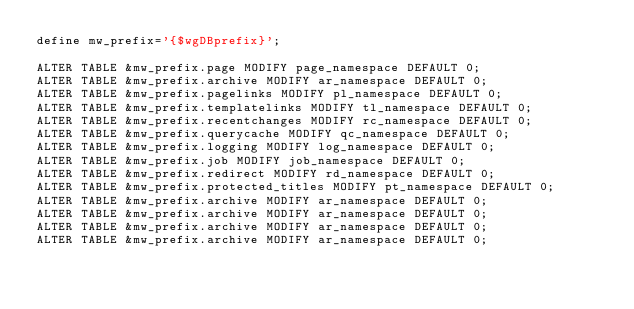<code> <loc_0><loc_0><loc_500><loc_500><_SQL_>define mw_prefix='{$wgDBprefix}';

ALTER TABLE &mw_prefix.page MODIFY page_namespace DEFAULT 0;
ALTER TABLE &mw_prefix.archive MODIFY ar_namespace DEFAULT 0;
ALTER TABLE &mw_prefix.pagelinks MODIFY pl_namespace DEFAULT 0;
ALTER TABLE &mw_prefix.templatelinks MODIFY tl_namespace DEFAULT 0;
ALTER TABLE &mw_prefix.recentchanges MODIFY rc_namespace DEFAULT 0;
ALTER TABLE &mw_prefix.querycache MODIFY qc_namespace DEFAULT 0;
ALTER TABLE &mw_prefix.logging MODIFY log_namespace DEFAULT 0;
ALTER TABLE &mw_prefix.job MODIFY job_namespace DEFAULT 0;
ALTER TABLE &mw_prefix.redirect MODIFY rd_namespace DEFAULT 0;
ALTER TABLE &mw_prefix.protected_titles MODIFY pt_namespace DEFAULT 0;
ALTER TABLE &mw_prefix.archive MODIFY ar_namespace DEFAULT 0;
ALTER TABLE &mw_prefix.archive MODIFY ar_namespace DEFAULT 0;
ALTER TABLE &mw_prefix.archive MODIFY ar_namespace DEFAULT 0;
ALTER TABLE &mw_prefix.archive MODIFY ar_namespace DEFAULT 0;

</code> 